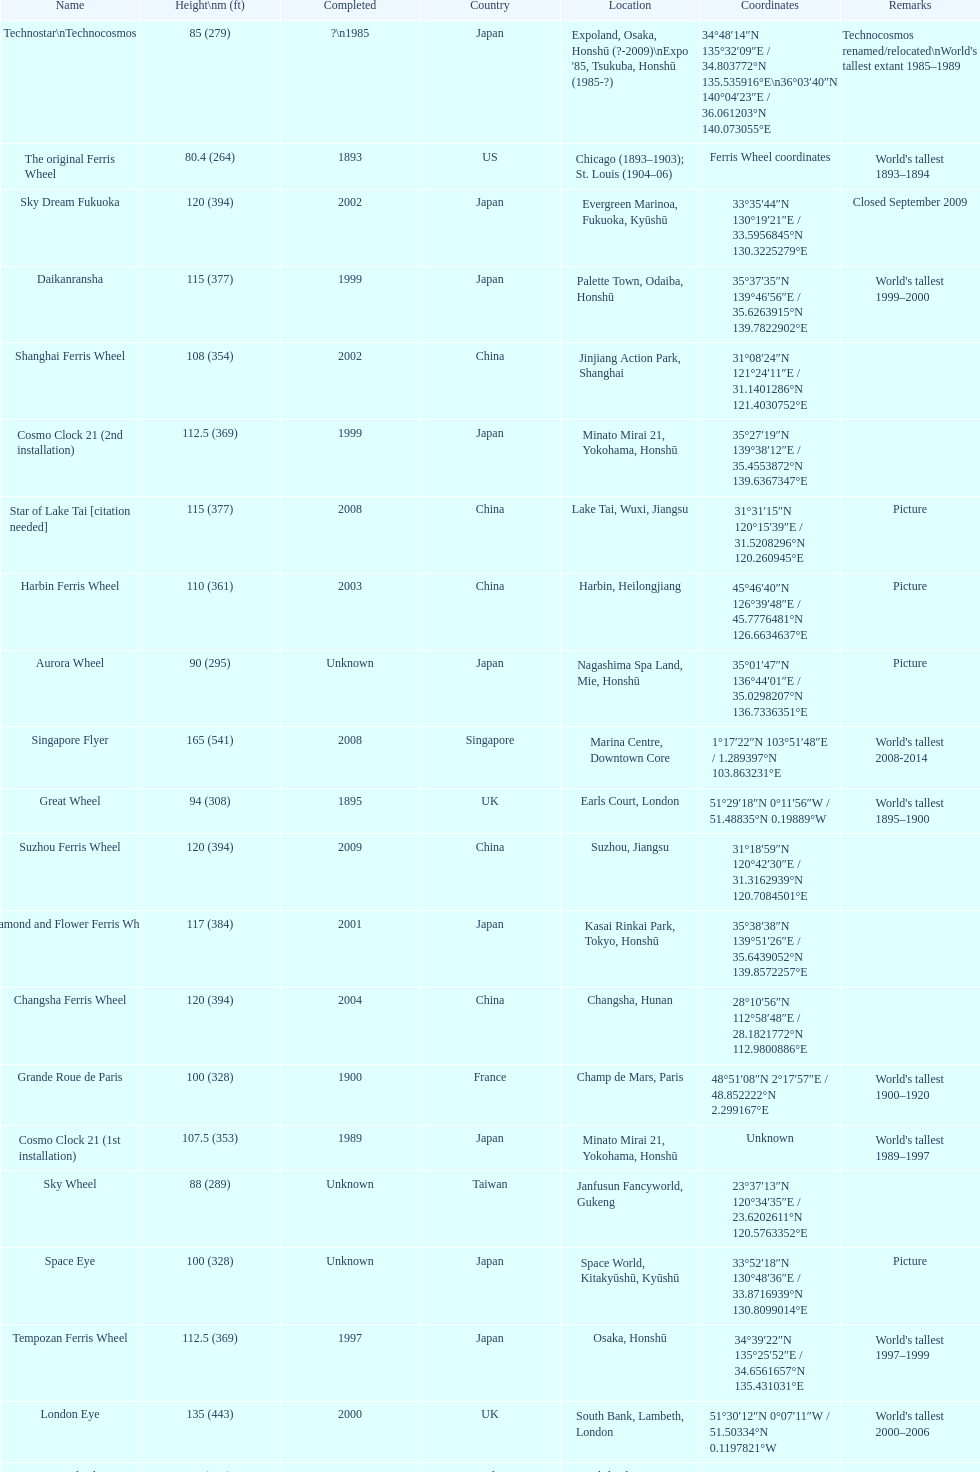Which country had the most roller coasters over 80 feet in height in 2008? China. Could you parse the entire table as a dict? {'header': ['Name', 'Height\\nm (ft)', 'Completed', 'Country', 'Location', 'Coordinates', 'Remarks'], 'rows': [['Technostar\\nTechnocosmos', '85 (279)', '?\\n1985', 'Japan', "Expoland, Osaka, Honshū (?-2009)\\nExpo '85, Tsukuba, Honshū (1985-?)", '34°48′14″N 135°32′09″E\ufeff / \ufeff34.803772°N 135.535916°E\\n36°03′40″N 140°04′23″E\ufeff / \ufeff36.061203°N 140.073055°E', "Technocosmos renamed/relocated\\nWorld's tallest extant 1985–1989"], ['The original Ferris Wheel', '80.4 (264)', '1893', 'US', 'Chicago (1893–1903); St. Louis (1904–06)', 'Ferris Wheel coordinates', "World's tallest 1893–1894"], ['Sky Dream Fukuoka', '120 (394)', '2002', 'Japan', 'Evergreen Marinoa, Fukuoka, Kyūshū', '33°35′44″N 130°19′21″E\ufeff / \ufeff33.5956845°N 130.3225279°E', 'Closed September 2009'], ['Daikanransha', '115 (377)', '1999', 'Japan', 'Palette Town, Odaiba, Honshū', '35°37′35″N 139°46′56″E\ufeff / \ufeff35.6263915°N 139.7822902°E', "World's tallest 1999–2000"], ['Shanghai Ferris Wheel', '108 (354)', '2002', 'China', 'Jinjiang Action Park, Shanghai', '31°08′24″N 121°24′11″E\ufeff / \ufeff31.1401286°N 121.4030752°E', ''], ['Cosmo Clock 21 (2nd installation)', '112.5 (369)', '1999', 'Japan', 'Minato Mirai 21, Yokohama, Honshū', '35°27′19″N 139°38′12″E\ufeff / \ufeff35.4553872°N 139.6367347°E', ''], ['Star of Lake Tai\xa0[citation needed]', '115 (377)', '2008', 'China', 'Lake Tai, Wuxi, Jiangsu', '31°31′15″N 120°15′39″E\ufeff / \ufeff31.5208296°N 120.260945°E', 'Picture'], ['Harbin Ferris Wheel', '110 (361)', '2003', 'China', 'Harbin, Heilongjiang', '45°46′40″N 126°39′48″E\ufeff / \ufeff45.7776481°N 126.6634637°E', 'Picture'], ['Aurora Wheel', '90 (295)', 'Unknown', 'Japan', 'Nagashima Spa Land, Mie, Honshū', '35°01′47″N 136°44′01″E\ufeff / \ufeff35.0298207°N 136.7336351°E', 'Picture'], ['Singapore Flyer', '165 (541)', '2008', 'Singapore', 'Marina Centre, Downtown Core', '1°17′22″N 103°51′48″E\ufeff / \ufeff1.289397°N 103.863231°E', "World's tallest 2008-2014"], ['Great Wheel', '94 (308)', '1895', 'UK', 'Earls Court, London', '51°29′18″N 0°11′56″W\ufeff / \ufeff51.48835°N 0.19889°W', "World's tallest 1895–1900"], ['Suzhou Ferris Wheel', '120 (394)', '2009', 'China', 'Suzhou, Jiangsu', '31°18′59″N 120°42′30″E\ufeff / \ufeff31.3162939°N 120.7084501°E', ''], ['Diamond\xa0and\xa0Flower\xa0Ferris\xa0Wheel', '117 (384)', '2001', 'Japan', 'Kasai Rinkai Park, Tokyo, Honshū', '35°38′38″N 139°51′26″E\ufeff / \ufeff35.6439052°N 139.8572257°E', ''], ['Changsha Ferris Wheel', '120 (394)', '2004', 'China', 'Changsha, Hunan', '28°10′56″N 112°58′48″E\ufeff / \ufeff28.1821772°N 112.9800886°E', ''], ['Grande Roue de Paris', '100 (328)', '1900', 'France', 'Champ de Mars, Paris', '48°51′08″N 2°17′57″E\ufeff / \ufeff48.852222°N 2.299167°E', "World's tallest 1900–1920"], ['Cosmo Clock 21 (1st installation)', '107.5 (353)', '1989', 'Japan', 'Minato Mirai 21, Yokohama, Honshū', 'Unknown', "World's tallest 1989–1997"], ['Sky Wheel', '88 (289)', 'Unknown', 'Taiwan', 'Janfusun Fancyworld, Gukeng', '23°37′13″N 120°34′35″E\ufeff / \ufeff23.6202611°N 120.5763352°E', ''], ['Space Eye', '100 (328)', 'Unknown', 'Japan', 'Space World, Kitakyūshū, Kyūshū', '33°52′18″N 130°48′36″E\ufeff / \ufeff33.8716939°N 130.8099014°E', 'Picture'], ['Tempozan Ferris Wheel', '112.5 (369)', '1997', 'Japan', 'Osaka, Honshū', '34°39′22″N 135°25′52″E\ufeff / \ufeff34.6561657°N 135.431031°E', "World's tallest 1997–1999"], ['London Eye', '135 (443)', '2000', 'UK', 'South Bank, Lambeth, London', '51°30′12″N 0°07′11″W\ufeff / \ufeff51.50334°N 0.1197821°W', "World's tallest 2000–2006"], ['Eurowheel', '90 (295)', '1999', 'Italy', 'Mirabilandia, Ravenna', '44°20′21″N 12°15′44″E\ufeff / \ufeff44.3392161°N 12.2622228°E', ''], ['Melbourne Star', '120 (394)', '2008', 'Australia', 'Docklands, Melbourne', '37°48′40″S 144°56′13″E\ufeff / \ufeff37.8110723°S 144.9368763°E', ''], ['Zhengzhou Ferris Wheel', '120 (394)', '2003', 'China', 'Century Amusement Park, Henan', '34°43′58″N 113°43′07″E\ufeff / \ufeff34.732871°N 113.718739°E', ''], ['Tianjin Eye', '120 (394)', '2008', 'China', 'Yongle Bridge, Tianjin', '39°09′12″N 117°10′49″E\ufeff / \ufeff39.1533636°N 117.1802616°E', ''], ['Star of Nanchang', '160 (525)', '2006', 'China', 'Nanchang, Jiangxi', '28°39′34″N 115°50′44″E\ufeff / \ufeff28.659332°N 115.845568°E', "World's tallest 2006–2008"], ['High Roller', '168 (551)', '2014', 'US', 'Las Vegas, Nevada', '36°07′03″N 115°10′05″W\ufeff / \ufeff36.117402°N 115.168127°W', "World's tallest since 2014"]]} 